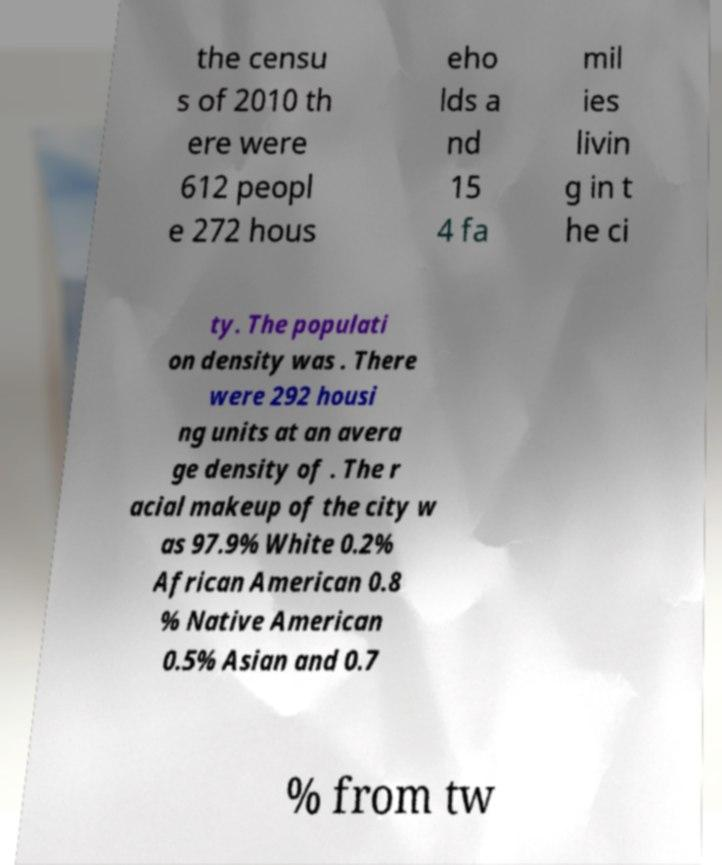Please identify and transcribe the text found in this image. the censu s of 2010 th ere were 612 peopl e 272 hous eho lds a nd 15 4 fa mil ies livin g in t he ci ty. The populati on density was . There were 292 housi ng units at an avera ge density of . The r acial makeup of the city w as 97.9% White 0.2% African American 0.8 % Native American 0.5% Asian and 0.7 % from tw 